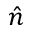<formula> <loc_0><loc_0><loc_500><loc_500>\hat { n }</formula> 